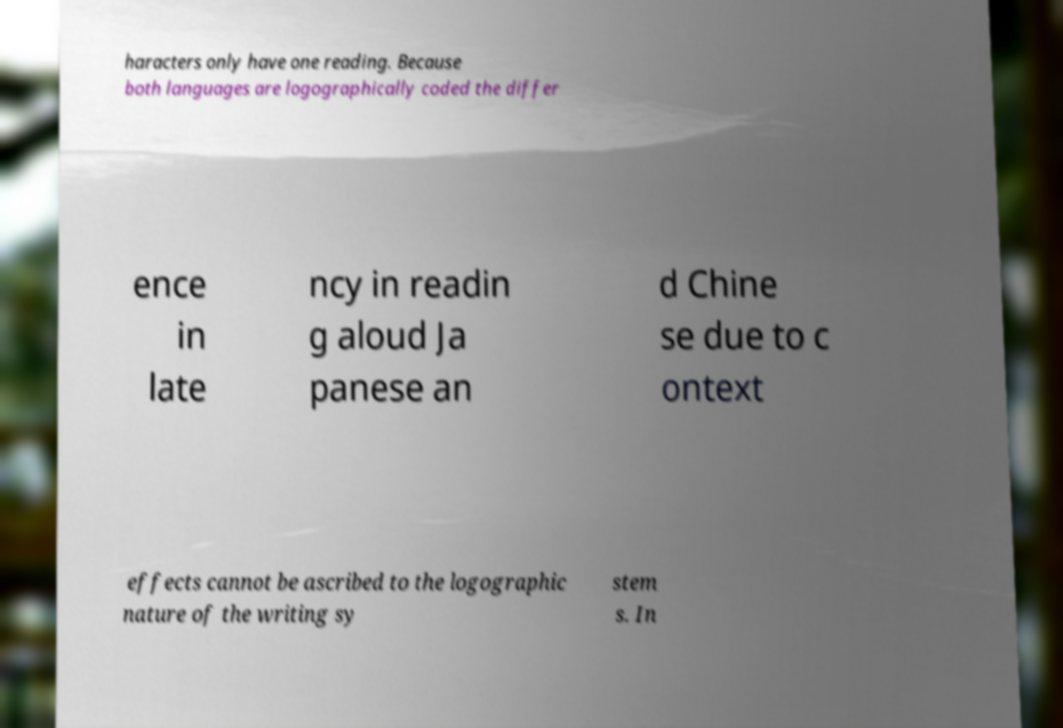Could you extract and type out the text from this image? haracters only have one reading. Because both languages are logographically coded the differ ence in late ncy in readin g aloud Ja panese an d Chine se due to c ontext effects cannot be ascribed to the logographic nature of the writing sy stem s. In 